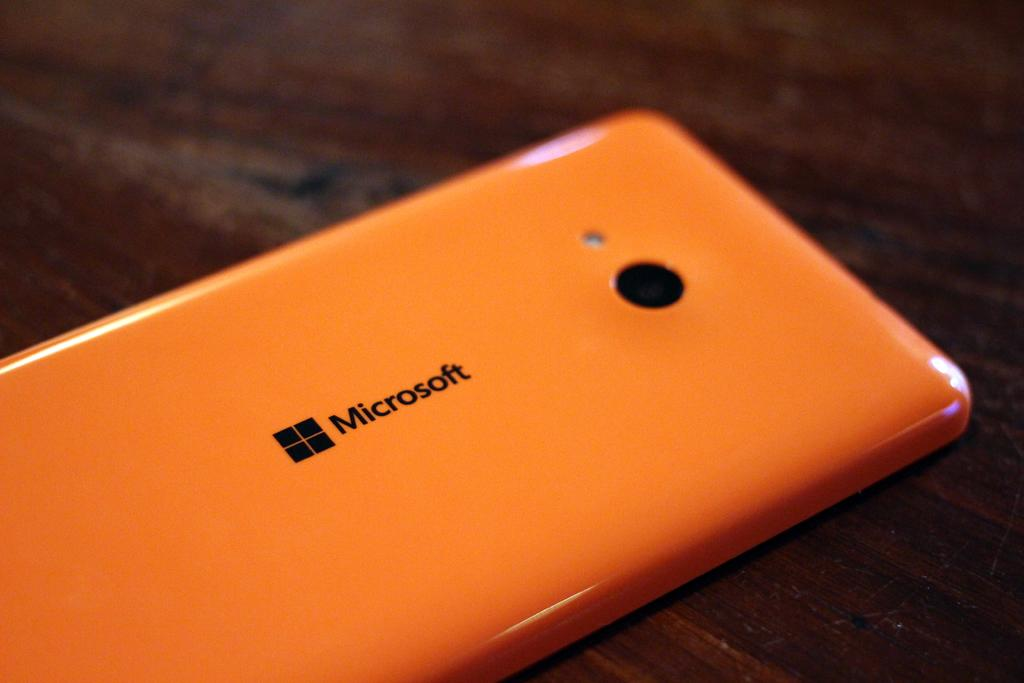<image>
Describe the image concisely. a microsoft phone is laying face down on a table 